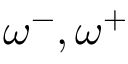Convert formula to latex. <formula><loc_0><loc_0><loc_500><loc_500>\omega ^ { - } , \omega ^ { + }</formula> 